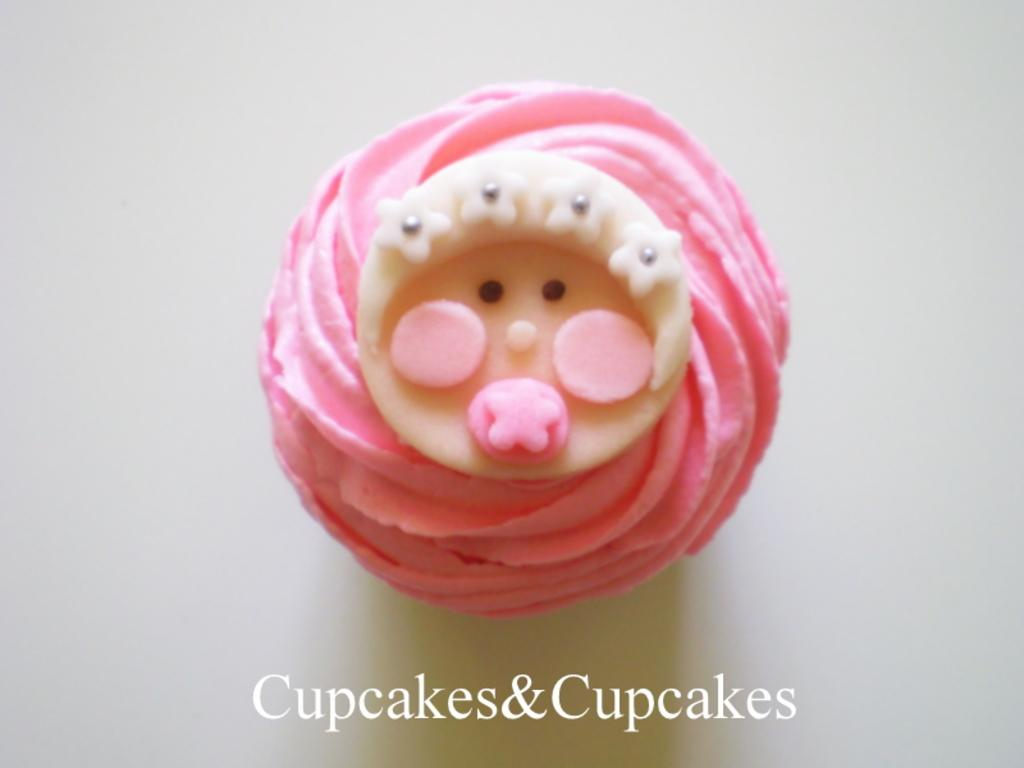What is the main subject of the image? There is a food item in the center of the image. What else can be seen at the bottom of the image? There is text at the bottom of the image. What color is the background of the image? The background of the image is white. How many umbrellas are being used to hold up the trousers in the image? There are no umbrellas or trousers present in the image. 